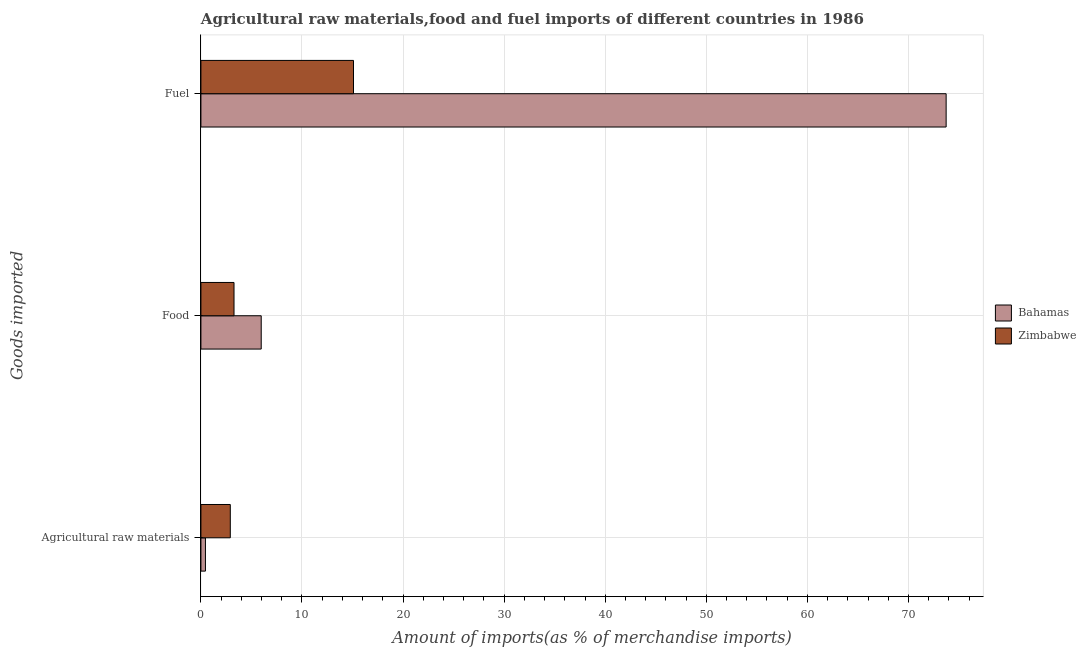What is the label of the 3rd group of bars from the top?
Your response must be concise. Agricultural raw materials. What is the percentage of raw materials imports in Zimbabwe?
Offer a very short reply. 2.91. Across all countries, what is the maximum percentage of food imports?
Your response must be concise. 5.97. Across all countries, what is the minimum percentage of fuel imports?
Give a very brief answer. 15.1. In which country was the percentage of raw materials imports maximum?
Your response must be concise. Zimbabwe. In which country was the percentage of food imports minimum?
Your response must be concise. Zimbabwe. What is the total percentage of food imports in the graph?
Make the answer very short. 9.24. What is the difference between the percentage of raw materials imports in Bahamas and that in Zimbabwe?
Your response must be concise. -2.46. What is the difference between the percentage of fuel imports in Zimbabwe and the percentage of raw materials imports in Bahamas?
Ensure brevity in your answer.  14.65. What is the average percentage of raw materials imports per country?
Your answer should be compact. 1.68. What is the difference between the percentage of food imports and percentage of raw materials imports in Zimbabwe?
Give a very brief answer. 0.37. In how many countries, is the percentage of raw materials imports greater than 4 %?
Provide a short and direct response. 0. What is the ratio of the percentage of raw materials imports in Bahamas to that in Zimbabwe?
Offer a very short reply. 0.15. What is the difference between the highest and the second highest percentage of food imports?
Your answer should be very brief. 2.69. What is the difference between the highest and the lowest percentage of raw materials imports?
Your answer should be very brief. 2.46. In how many countries, is the percentage of food imports greater than the average percentage of food imports taken over all countries?
Ensure brevity in your answer.  1. What does the 2nd bar from the top in Food represents?
Your response must be concise. Bahamas. What does the 2nd bar from the bottom in Food represents?
Provide a succinct answer. Zimbabwe. Is it the case that in every country, the sum of the percentage of raw materials imports and percentage of food imports is greater than the percentage of fuel imports?
Give a very brief answer. No. How many countries are there in the graph?
Your response must be concise. 2. Are the values on the major ticks of X-axis written in scientific E-notation?
Your response must be concise. No. Does the graph contain any zero values?
Offer a very short reply. No. Where does the legend appear in the graph?
Ensure brevity in your answer.  Center right. What is the title of the graph?
Your answer should be compact. Agricultural raw materials,food and fuel imports of different countries in 1986. What is the label or title of the X-axis?
Provide a short and direct response. Amount of imports(as % of merchandise imports). What is the label or title of the Y-axis?
Provide a short and direct response. Goods imported. What is the Amount of imports(as % of merchandise imports) of Bahamas in Agricultural raw materials?
Provide a succinct answer. 0.45. What is the Amount of imports(as % of merchandise imports) of Zimbabwe in Agricultural raw materials?
Your answer should be compact. 2.91. What is the Amount of imports(as % of merchandise imports) in Bahamas in Food?
Ensure brevity in your answer.  5.97. What is the Amount of imports(as % of merchandise imports) of Zimbabwe in Food?
Your answer should be very brief. 3.27. What is the Amount of imports(as % of merchandise imports) in Bahamas in Fuel?
Your answer should be compact. 73.73. What is the Amount of imports(as % of merchandise imports) in Zimbabwe in Fuel?
Offer a very short reply. 15.1. Across all Goods imported, what is the maximum Amount of imports(as % of merchandise imports) of Bahamas?
Keep it short and to the point. 73.73. Across all Goods imported, what is the maximum Amount of imports(as % of merchandise imports) in Zimbabwe?
Your response must be concise. 15.1. Across all Goods imported, what is the minimum Amount of imports(as % of merchandise imports) of Bahamas?
Give a very brief answer. 0.45. Across all Goods imported, what is the minimum Amount of imports(as % of merchandise imports) of Zimbabwe?
Provide a short and direct response. 2.91. What is the total Amount of imports(as % of merchandise imports) of Bahamas in the graph?
Offer a very short reply. 80.15. What is the total Amount of imports(as % of merchandise imports) of Zimbabwe in the graph?
Offer a terse response. 21.28. What is the difference between the Amount of imports(as % of merchandise imports) of Bahamas in Agricultural raw materials and that in Food?
Provide a succinct answer. -5.52. What is the difference between the Amount of imports(as % of merchandise imports) of Zimbabwe in Agricultural raw materials and that in Food?
Ensure brevity in your answer.  -0.37. What is the difference between the Amount of imports(as % of merchandise imports) of Bahamas in Agricultural raw materials and that in Fuel?
Provide a succinct answer. -73.28. What is the difference between the Amount of imports(as % of merchandise imports) of Zimbabwe in Agricultural raw materials and that in Fuel?
Offer a very short reply. -12.19. What is the difference between the Amount of imports(as % of merchandise imports) in Bahamas in Food and that in Fuel?
Provide a succinct answer. -67.77. What is the difference between the Amount of imports(as % of merchandise imports) of Zimbabwe in Food and that in Fuel?
Make the answer very short. -11.82. What is the difference between the Amount of imports(as % of merchandise imports) in Bahamas in Agricultural raw materials and the Amount of imports(as % of merchandise imports) in Zimbabwe in Food?
Ensure brevity in your answer.  -2.83. What is the difference between the Amount of imports(as % of merchandise imports) in Bahamas in Agricultural raw materials and the Amount of imports(as % of merchandise imports) in Zimbabwe in Fuel?
Keep it short and to the point. -14.65. What is the difference between the Amount of imports(as % of merchandise imports) of Bahamas in Food and the Amount of imports(as % of merchandise imports) of Zimbabwe in Fuel?
Keep it short and to the point. -9.13. What is the average Amount of imports(as % of merchandise imports) of Bahamas per Goods imported?
Provide a succinct answer. 26.72. What is the average Amount of imports(as % of merchandise imports) of Zimbabwe per Goods imported?
Provide a succinct answer. 7.09. What is the difference between the Amount of imports(as % of merchandise imports) in Bahamas and Amount of imports(as % of merchandise imports) in Zimbabwe in Agricultural raw materials?
Keep it short and to the point. -2.46. What is the difference between the Amount of imports(as % of merchandise imports) in Bahamas and Amount of imports(as % of merchandise imports) in Zimbabwe in Food?
Offer a terse response. 2.69. What is the difference between the Amount of imports(as % of merchandise imports) in Bahamas and Amount of imports(as % of merchandise imports) in Zimbabwe in Fuel?
Your answer should be compact. 58.64. What is the ratio of the Amount of imports(as % of merchandise imports) of Bahamas in Agricultural raw materials to that in Food?
Give a very brief answer. 0.08. What is the ratio of the Amount of imports(as % of merchandise imports) of Zimbabwe in Agricultural raw materials to that in Food?
Ensure brevity in your answer.  0.89. What is the ratio of the Amount of imports(as % of merchandise imports) of Bahamas in Agricultural raw materials to that in Fuel?
Ensure brevity in your answer.  0.01. What is the ratio of the Amount of imports(as % of merchandise imports) in Zimbabwe in Agricultural raw materials to that in Fuel?
Your answer should be very brief. 0.19. What is the ratio of the Amount of imports(as % of merchandise imports) of Bahamas in Food to that in Fuel?
Your answer should be compact. 0.08. What is the ratio of the Amount of imports(as % of merchandise imports) of Zimbabwe in Food to that in Fuel?
Provide a short and direct response. 0.22. What is the difference between the highest and the second highest Amount of imports(as % of merchandise imports) in Bahamas?
Offer a very short reply. 67.77. What is the difference between the highest and the second highest Amount of imports(as % of merchandise imports) of Zimbabwe?
Your response must be concise. 11.82. What is the difference between the highest and the lowest Amount of imports(as % of merchandise imports) in Bahamas?
Your response must be concise. 73.28. What is the difference between the highest and the lowest Amount of imports(as % of merchandise imports) of Zimbabwe?
Offer a very short reply. 12.19. 